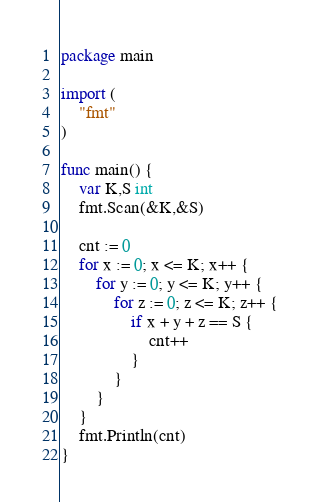<code> <loc_0><loc_0><loc_500><loc_500><_Go_>package main

import (
	"fmt"
)

func main() {
	var K,S int
	fmt.Scan(&K,&S)
	
	cnt := 0
	for x := 0; x <= K; x++ {
		for y := 0; y <= K; y++ {
			for z := 0; z <= K; z++ {
				if x + y + z == S {
					cnt++
				}
			}
		}
	}
	fmt.Println(cnt)
}</code> 